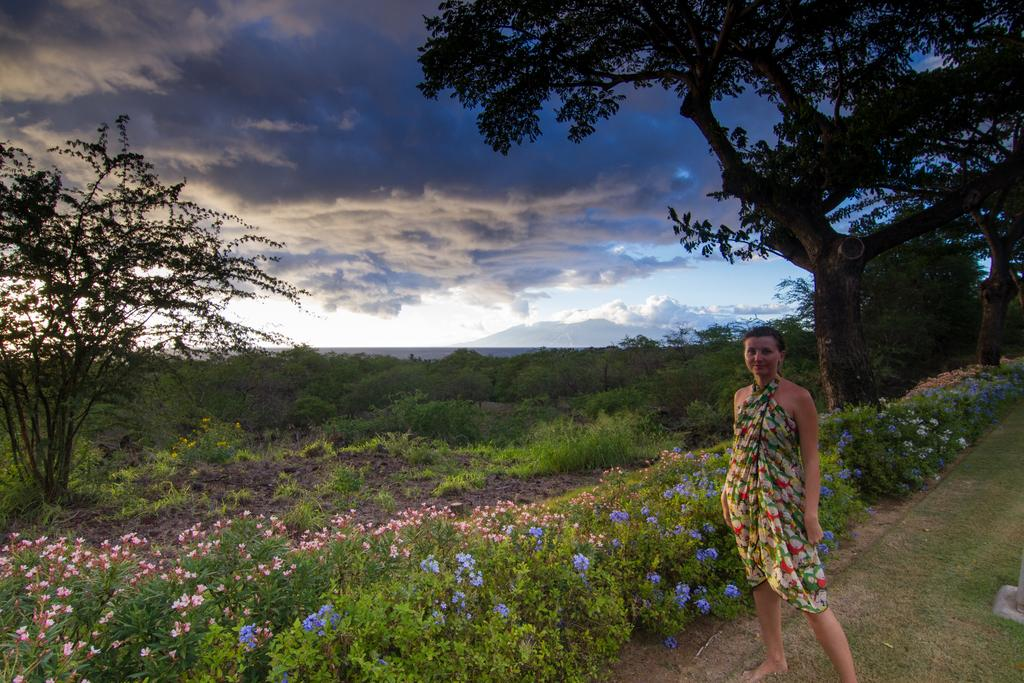What is the main subject of the image? There is a woman standing in the center of the image. What can be seen in the background of the image? Sky, clouds, trees, a hill, plants, grass, and flowers are visible in the background of the image. Can you describe the natural elements present in the background? The background features trees, plants, grass, and flowers. What is the weather like in the image? The presence of clouds suggests that the weather might be partly cloudy. How does the flock of birds navigate the rainstorm in the image? There are no birds or rainstorm present in the image. What type of curve can be seen in the image? There is no curve visible in the image. 